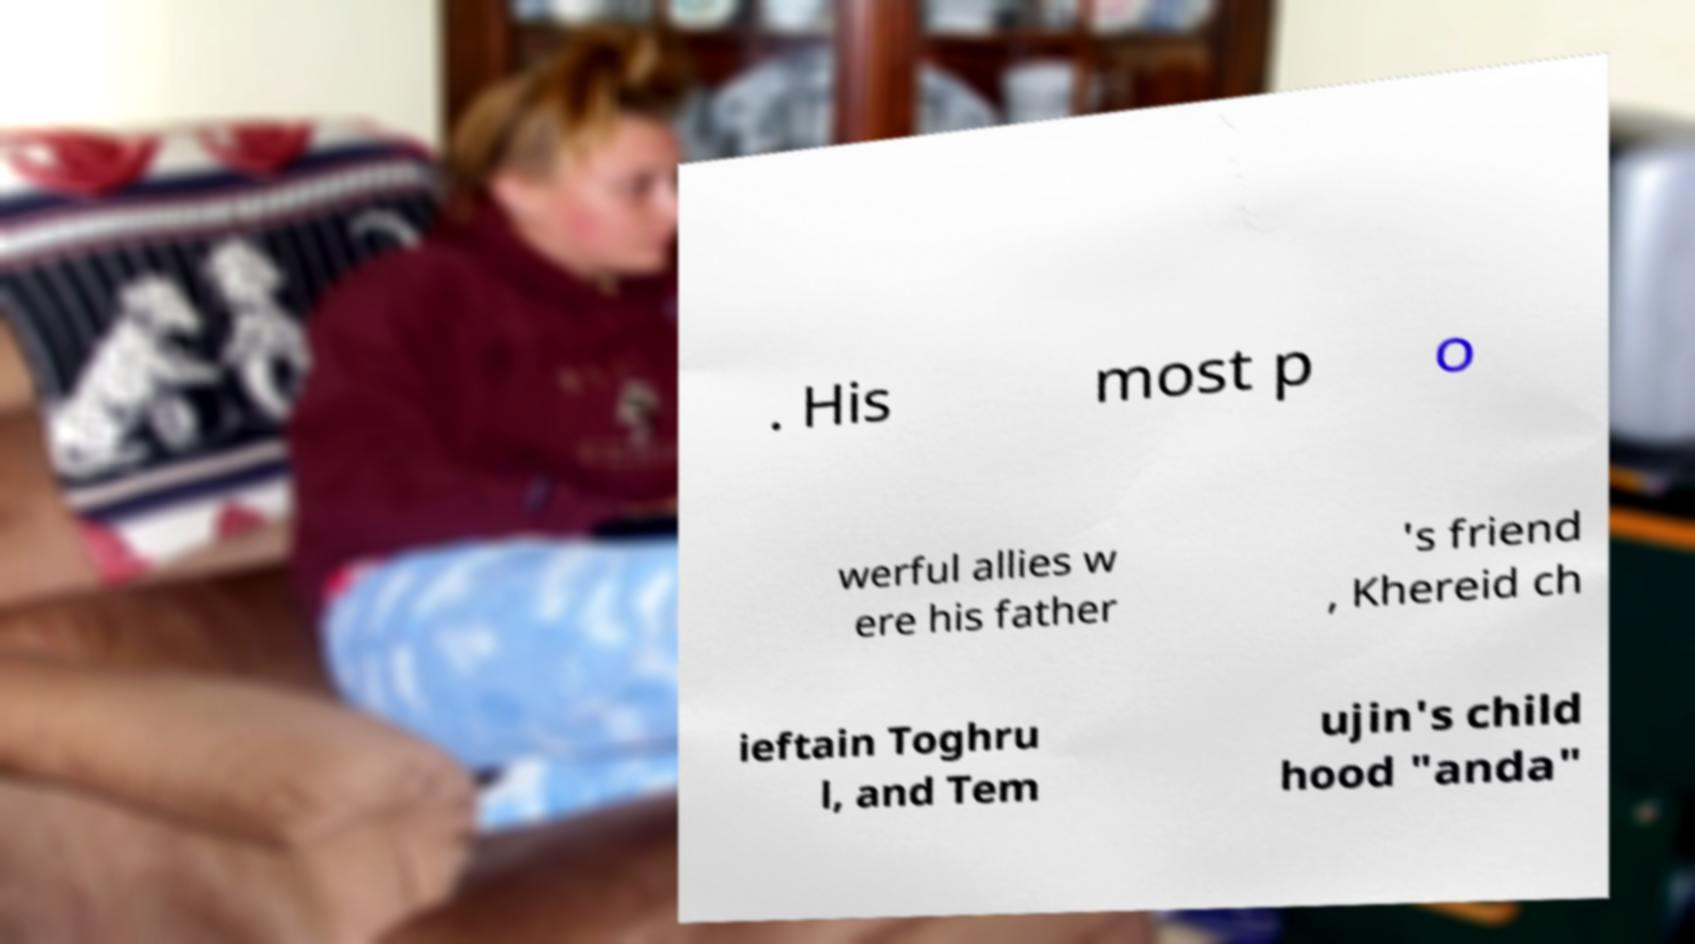Please read and relay the text visible in this image. What does it say? . His most p o werful allies w ere his father 's friend , Khereid ch ieftain Toghru l, and Tem ujin's child hood "anda" 